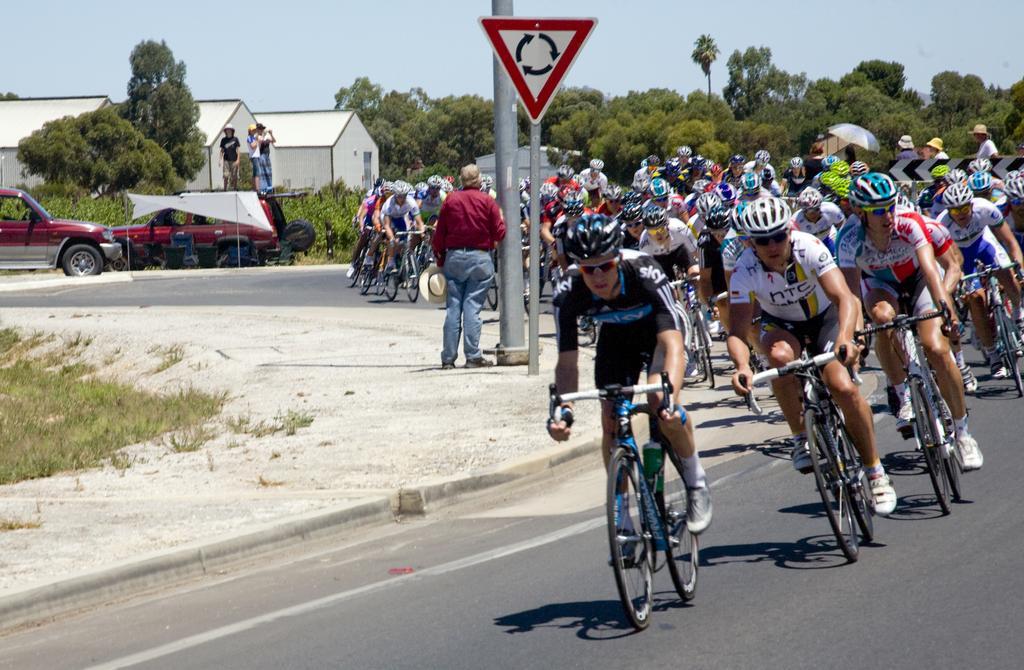How would you summarize this image in a sentence or two? In this image we can see people riding bicycles on the road, persons standing and holding a hat, people standing on the motor vehicle, buildings, trees, sign boards, poles and sky. 